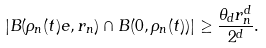<formula> <loc_0><loc_0><loc_500><loc_500>| B ( \rho _ { n } ( t ) e , r _ { n } ) \cap B ( 0 , \rho _ { n } ( t ) ) | \geq \frac { \theta _ { d } r _ { n } ^ { d } } { 2 ^ { d } } .</formula> 